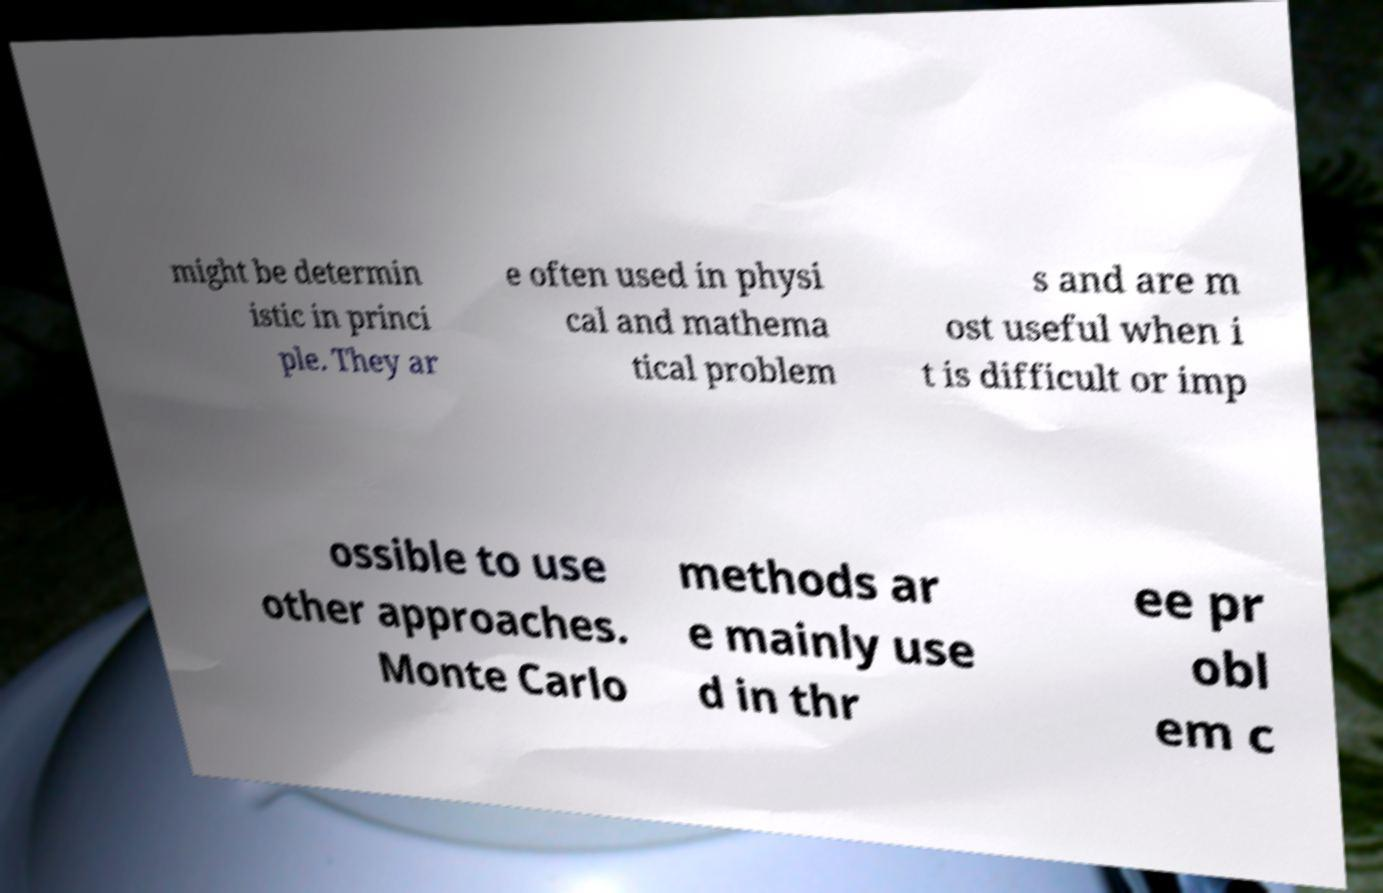Could you assist in decoding the text presented in this image and type it out clearly? might be determin istic in princi ple. They ar e often used in physi cal and mathema tical problem s and are m ost useful when i t is difficult or imp ossible to use other approaches. Monte Carlo methods ar e mainly use d in thr ee pr obl em c 